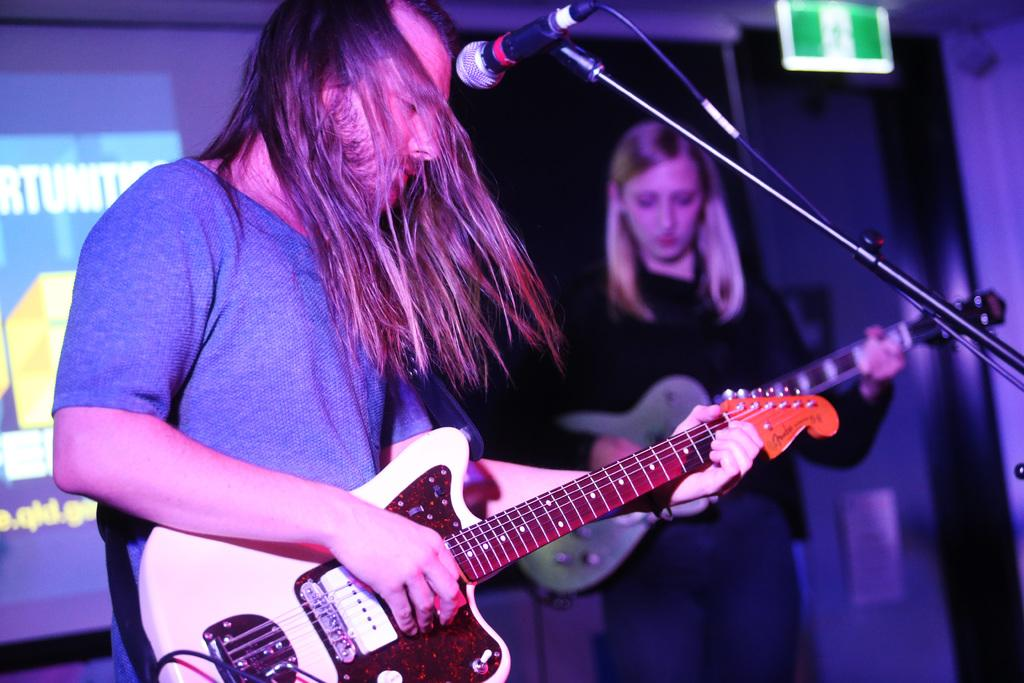What is the main activity being performed by the person in the image? The person is playing a guitar in the image. What object is the person in front of while playing the guitar? The person is in front of a microphone. Are there any other musicians in the image? Yes, a woman is also playing a guitar in the image. What can be seen on the wall in the background? There is a screen on the wall. Where is the table located in the image? There is no table present in the image. Can you describe the bath in the image? There is no bath present in the image. 